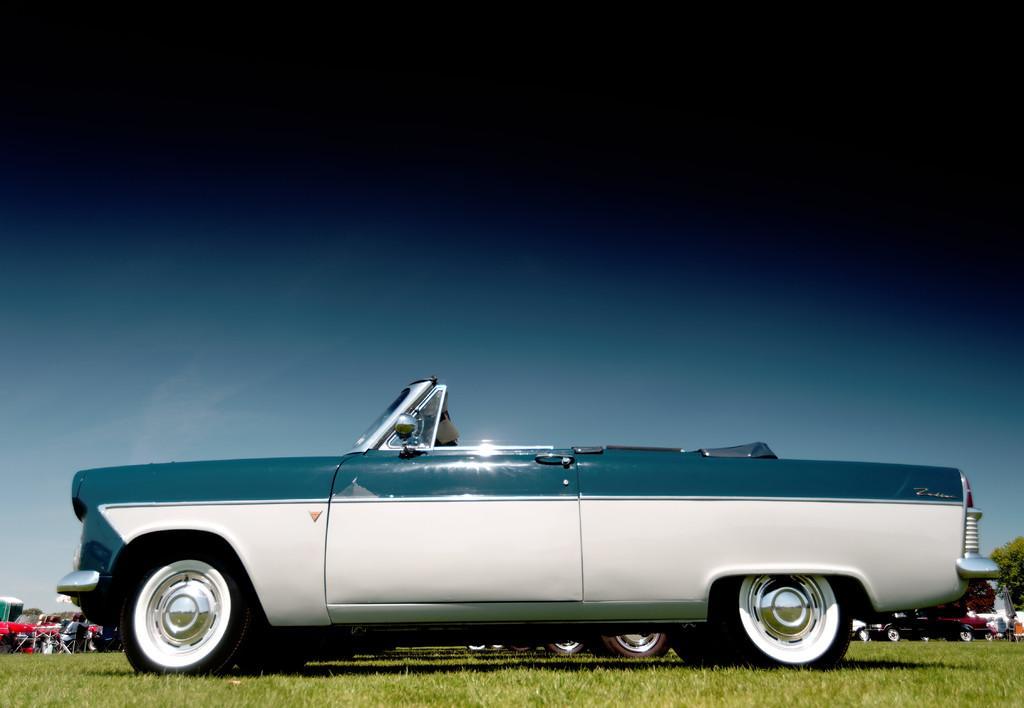Please provide a concise description of this image. In this image I can see many vehicles on the grass. To the side I can see few people. In the background I can see many trees and the sky. 